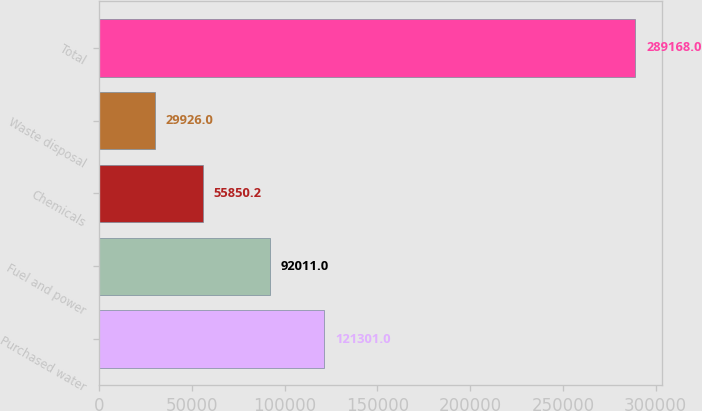Convert chart. <chart><loc_0><loc_0><loc_500><loc_500><bar_chart><fcel>Purchased water<fcel>Fuel and power<fcel>Chemicals<fcel>Waste disposal<fcel>Total<nl><fcel>121301<fcel>92011<fcel>55850.2<fcel>29926<fcel>289168<nl></chart> 